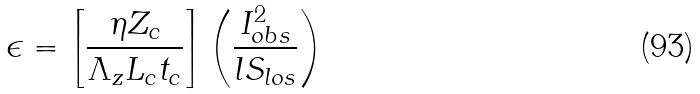<formula> <loc_0><loc_0><loc_500><loc_500>\epsilon = \left [ \frac { \eta Z _ { c } } { \Lambda _ { z } L _ { c } t _ { c } } \right ] \left ( \frac { I _ { o b s } ^ { 2 } } { l S _ { l o s } } \right )</formula> 